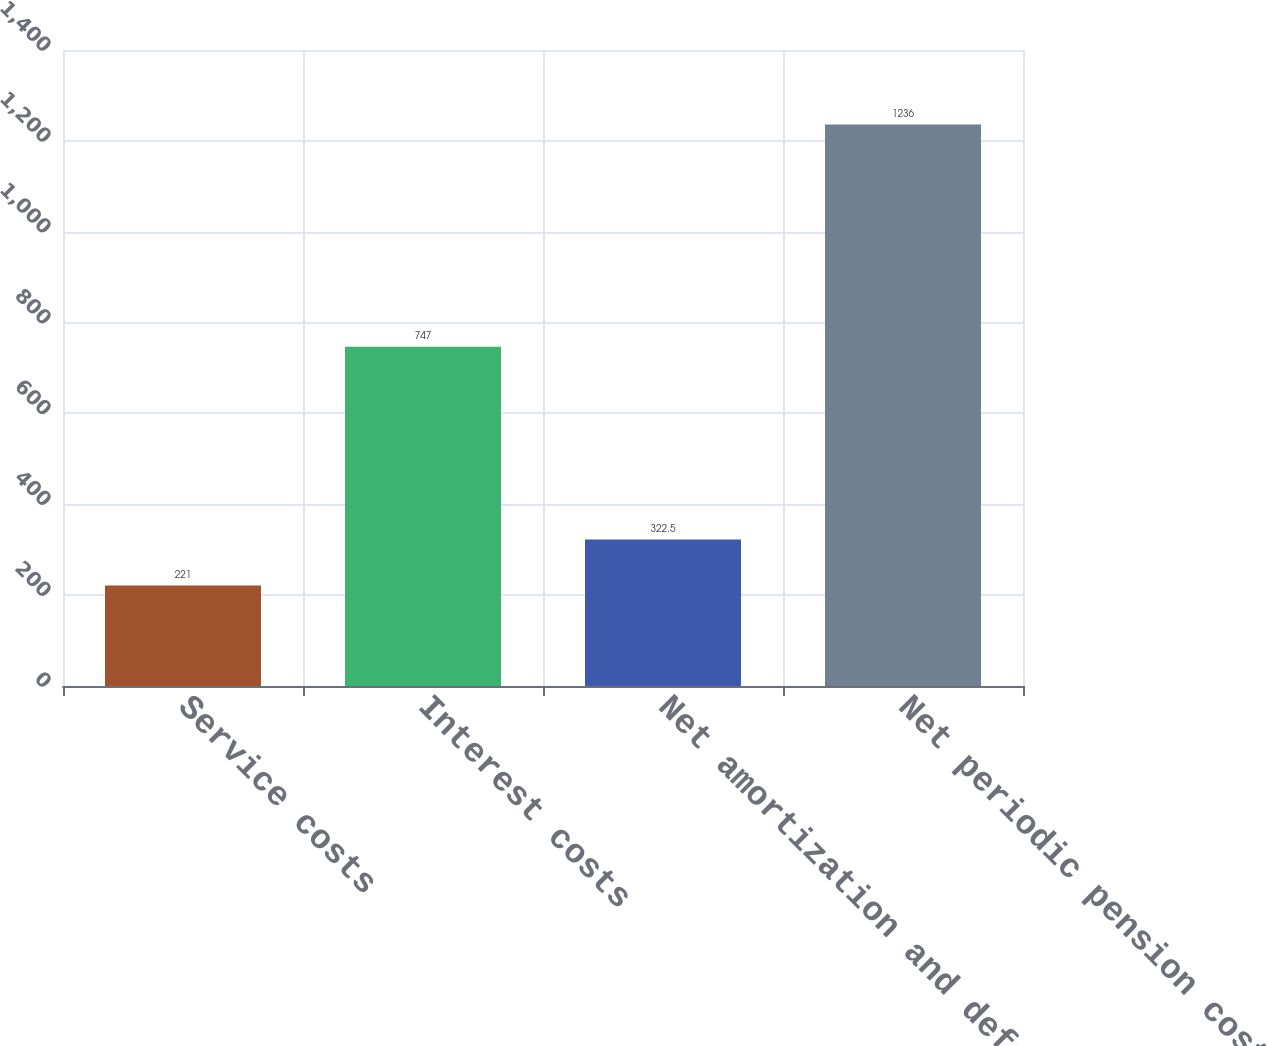<chart> <loc_0><loc_0><loc_500><loc_500><bar_chart><fcel>Service costs<fcel>Interest costs<fcel>Net amortization and deferral<fcel>Net periodic pension costs<nl><fcel>221<fcel>747<fcel>322.5<fcel>1236<nl></chart> 